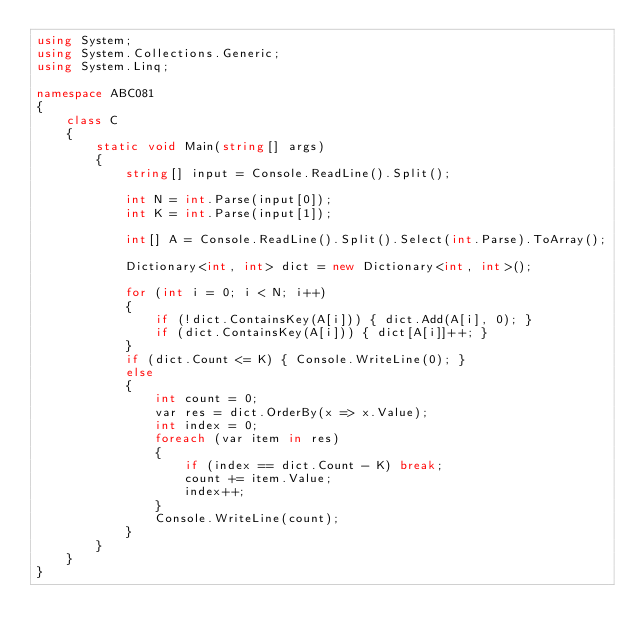<code> <loc_0><loc_0><loc_500><loc_500><_C#_>using System;
using System.Collections.Generic;
using System.Linq;

namespace ABC081
{
    class C
    {
        static void Main(string[] args)
        {
            string[] input = Console.ReadLine().Split();

            int N = int.Parse(input[0]);
            int K = int.Parse(input[1]);

            int[] A = Console.ReadLine().Split().Select(int.Parse).ToArray();

            Dictionary<int, int> dict = new Dictionary<int, int>();

            for (int i = 0; i < N; i++)
            {
                if (!dict.ContainsKey(A[i])) { dict.Add(A[i], 0); }
                if (dict.ContainsKey(A[i])) { dict[A[i]]++; }
            }
            if (dict.Count <= K) { Console.WriteLine(0); }
            else
            {
                int count = 0;
                var res = dict.OrderBy(x => x.Value);
                int index = 0;
                foreach (var item in res)
                {
                    if (index == dict.Count - K) break;
                    count += item.Value;
                    index++;
                }
                Console.WriteLine(count);
            }
        }
    }
}
</code> 